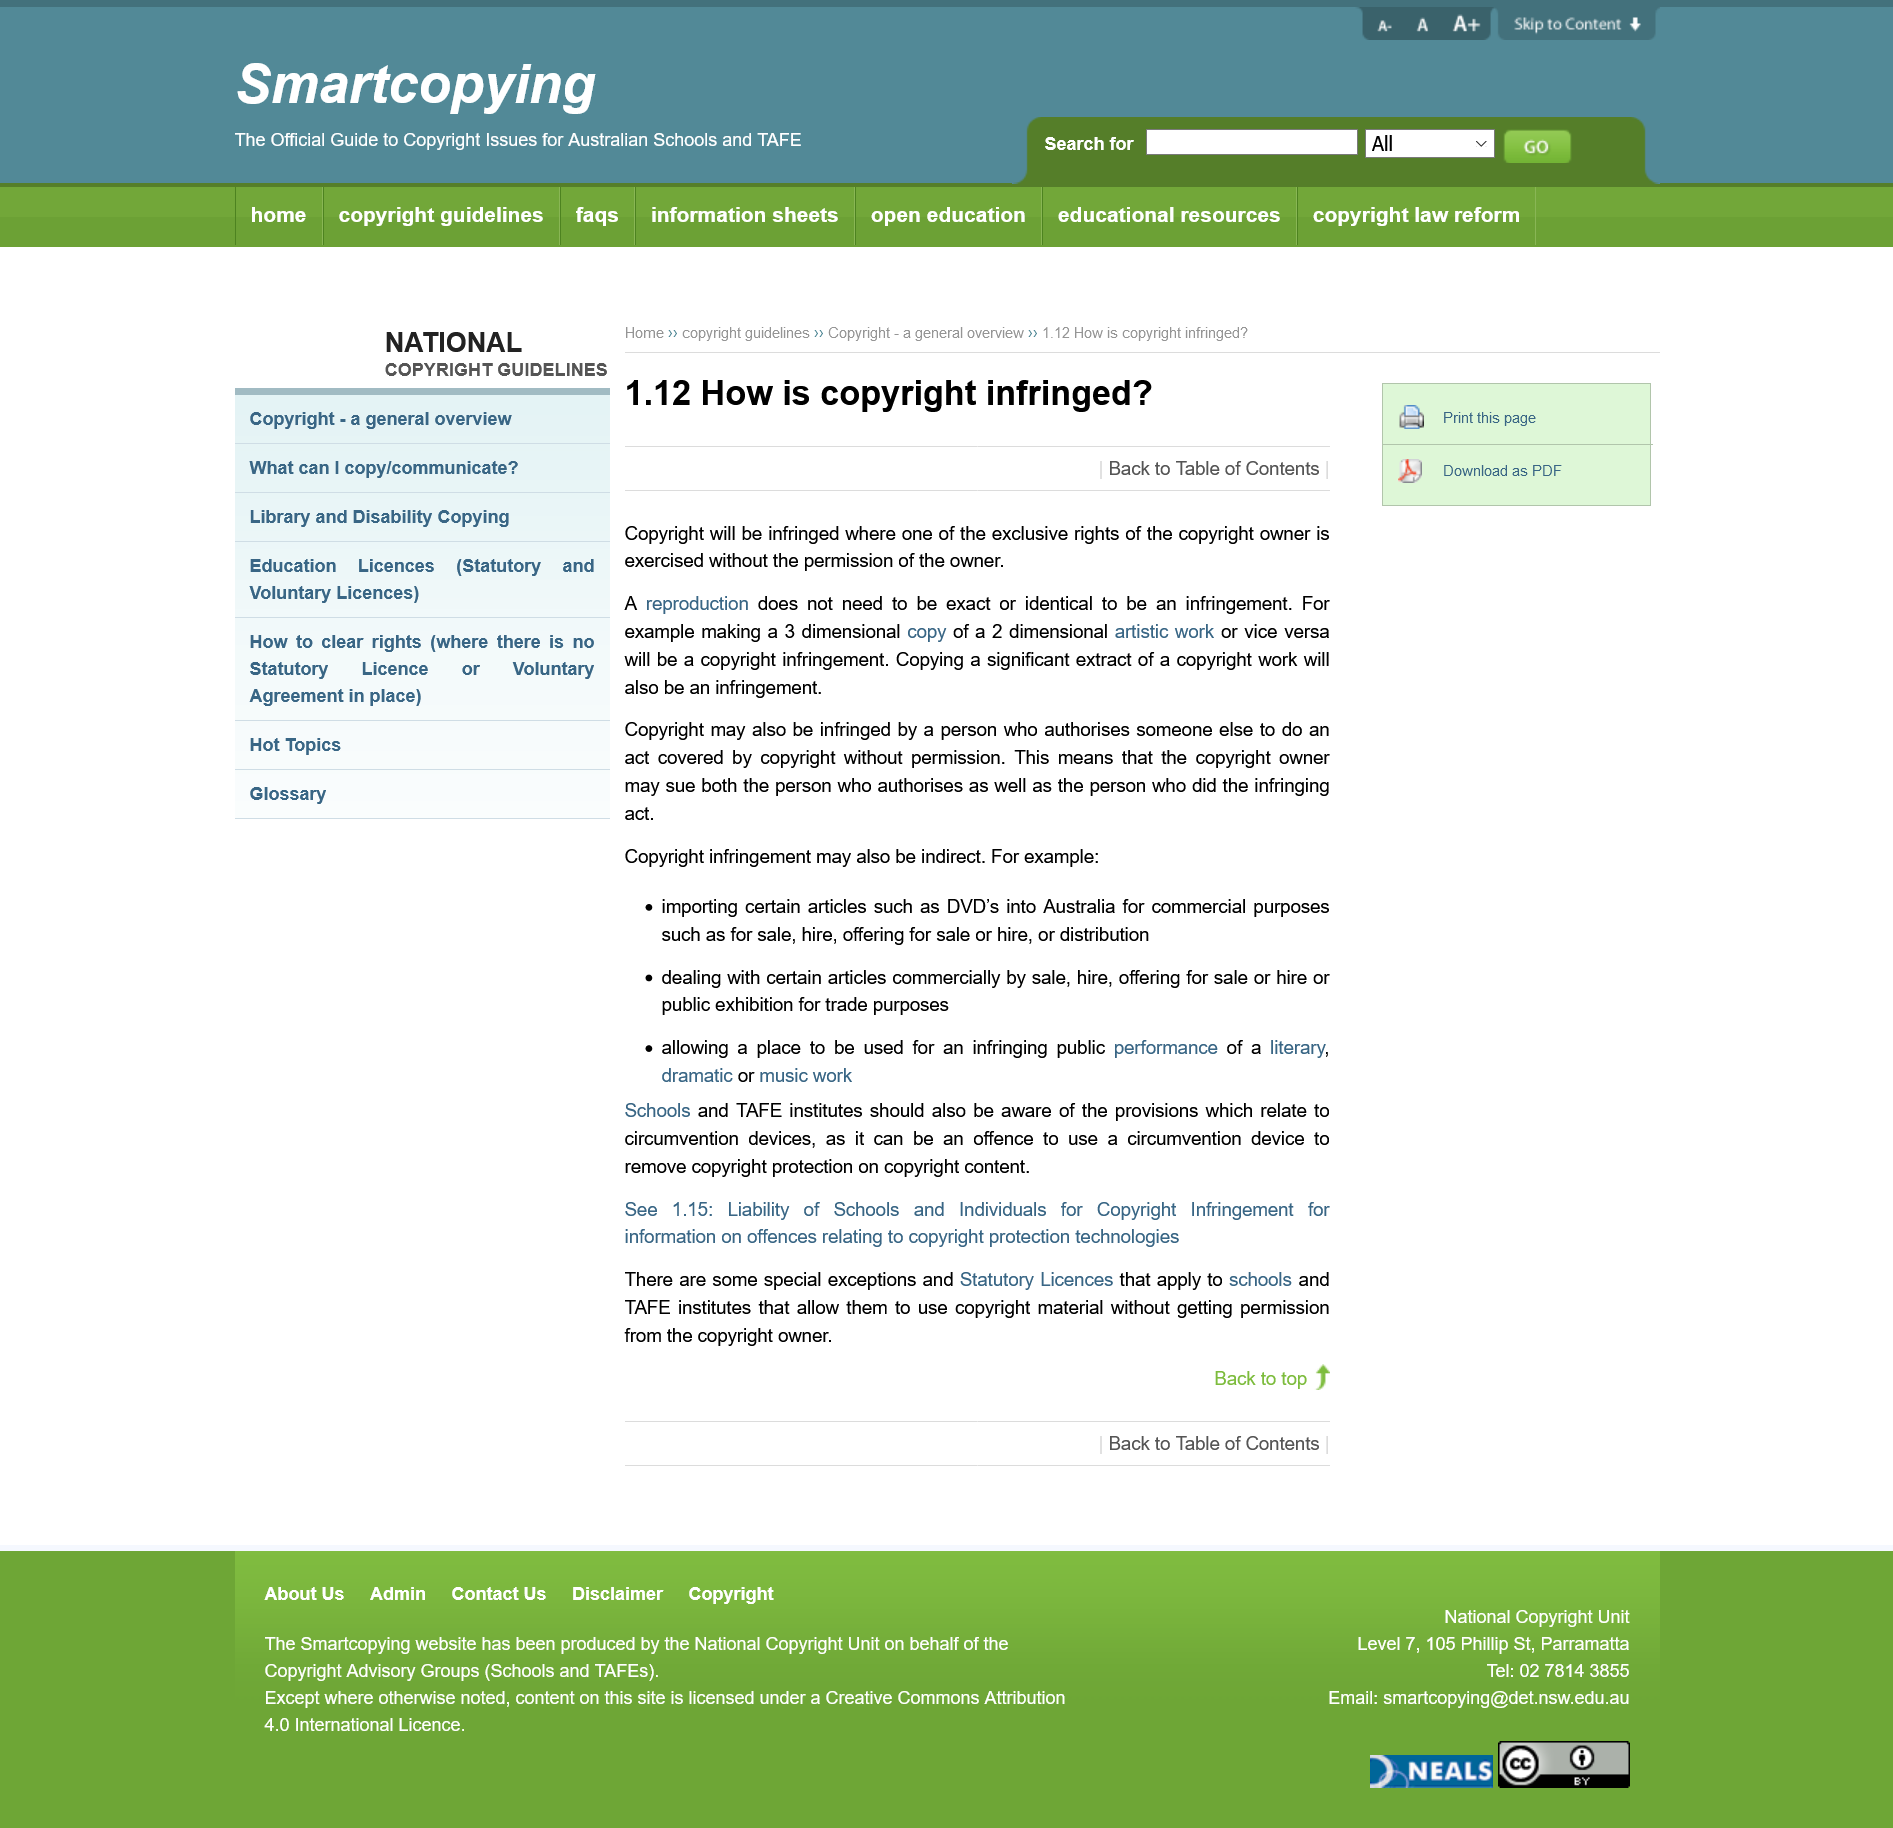Mention a couple of crucial points in this snapshot. It is necessary to obtain the copyright owner's permission to reproduce work without infringing copyright. If a person authorizes someone else to reproduce a work without the copyright owner's permission, both the person who reproduced the work and the person who authorized it can be sued by the copyright owner. Representative: "A reproduction does not need to be an exact copy to be considered an infringement. 